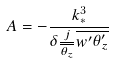<formula> <loc_0><loc_0><loc_500><loc_500>A = - \frac { k _ { * } ^ { 3 } } { \delta \frac { j } { \overline { \theta _ { z } } } \overline { w ^ { \prime } \theta _ { z } ^ { \prime } } }</formula> 